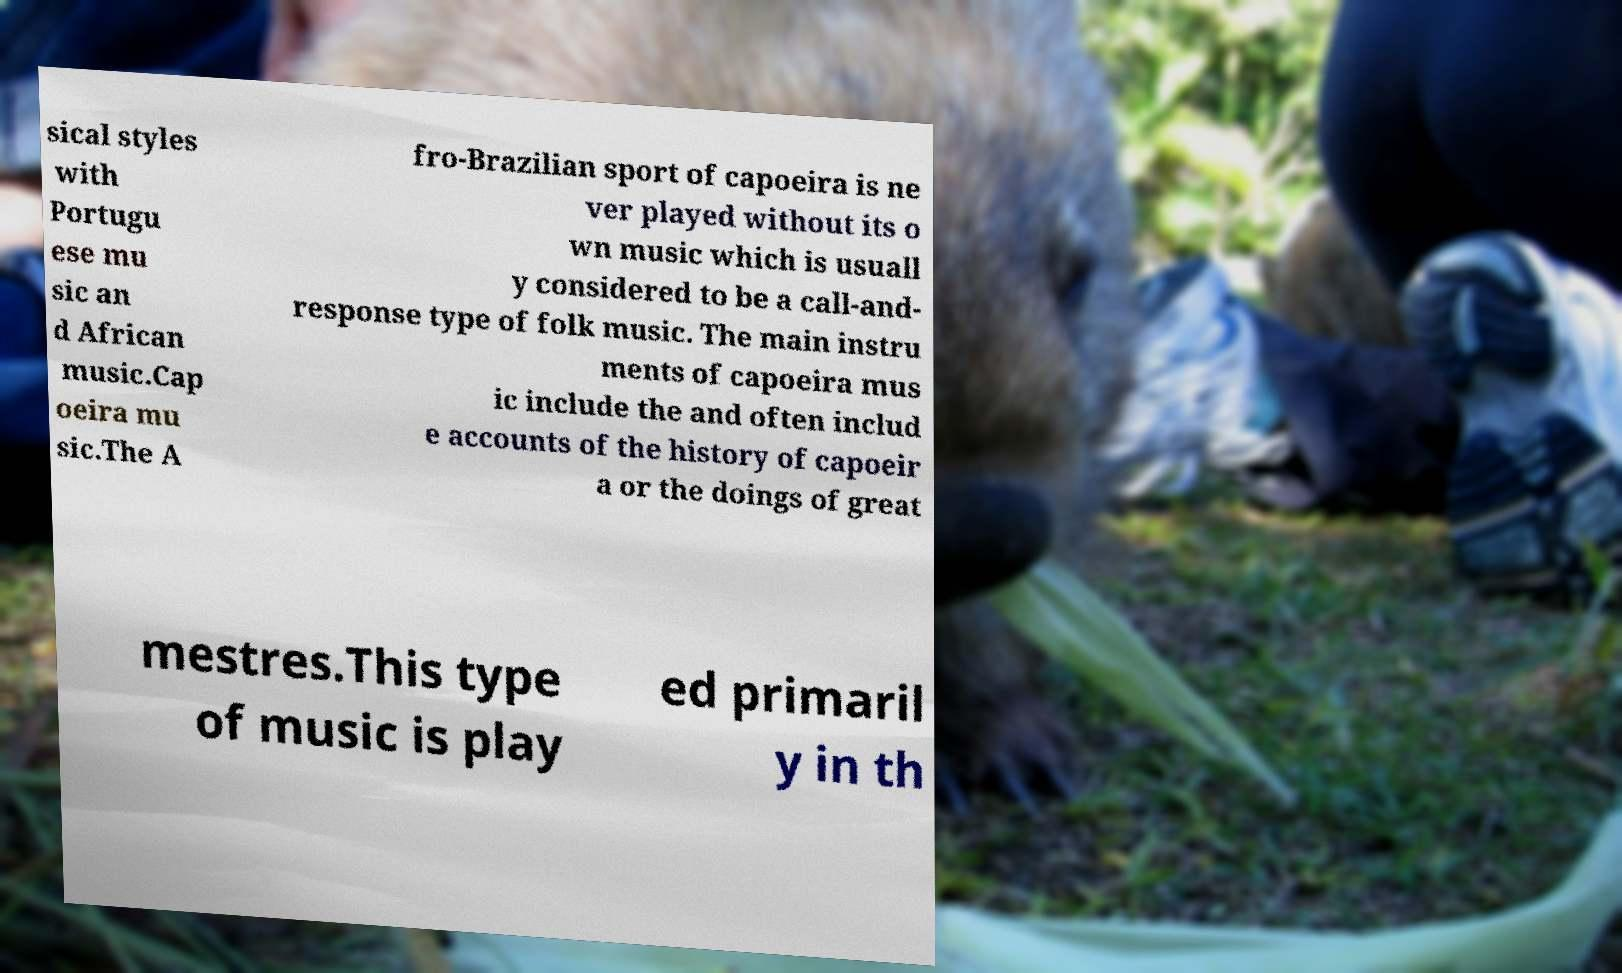Can you accurately transcribe the text from the provided image for me? sical styles with Portugu ese mu sic an d African music.Cap oeira mu sic.The A fro-Brazilian sport of capoeira is ne ver played without its o wn music which is usuall y considered to be a call-and- response type of folk music. The main instru ments of capoeira mus ic include the and often includ e accounts of the history of capoeir a or the doings of great mestres.This type of music is play ed primaril y in th 